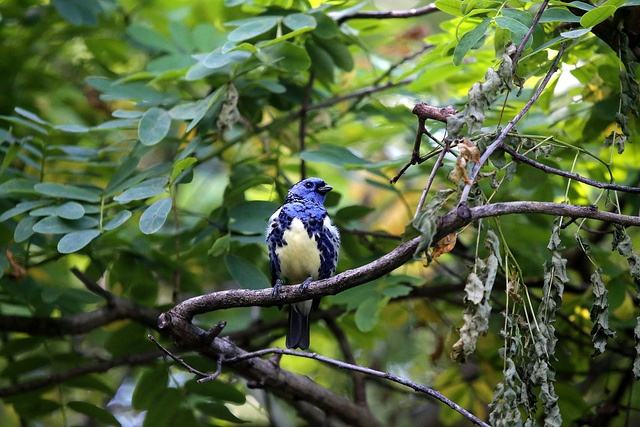Describe the objects in this image and their specific colors. I can see a bird in olive, black, navy, gray, and lightgray tones in this image. 